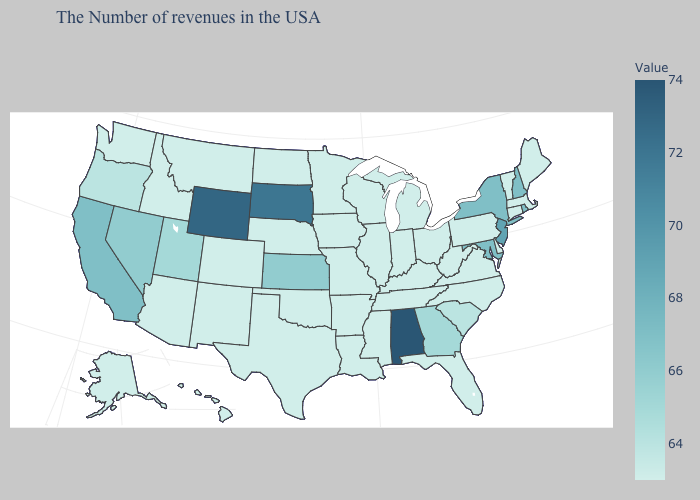Does Virginia have the lowest value in the USA?
Write a very short answer. Yes. Does New Jersey have a higher value than Mississippi?
Write a very short answer. Yes. Which states have the highest value in the USA?
Quick response, please. Alabama. Does Connecticut have the lowest value in the Northeast?
Give a very brief answer. Yes. Among the states that border Pennsylvania , does New Jersey have the lowest value?
Give a very brief answer. No. 